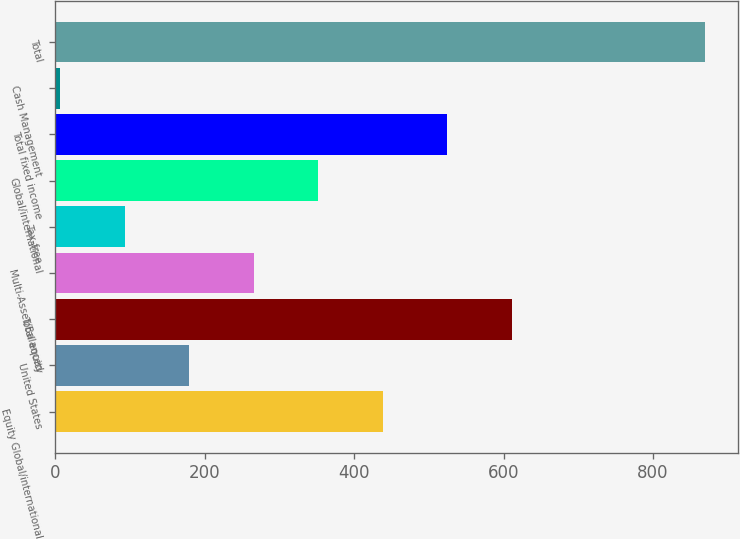<chart> <loc_0><loc_0><loc_500><loc_500><bar_chart><fcel>Equity Global/international<fcel>United States<fcel>Total equity<fcel>Multi-Asset/Balanced<fcel>Tax-free<fcel>Global/international<fcel>Total fixed income<fcel>Cash Management<fcel>Total<nl><fcel>438.3<fcel>179.58<fcel>610.78<fcel>265.82<fcel>93.34<fcel>352.06<fcel>524.54<fcel>7.1<fcel>869.5<nl></chart> 